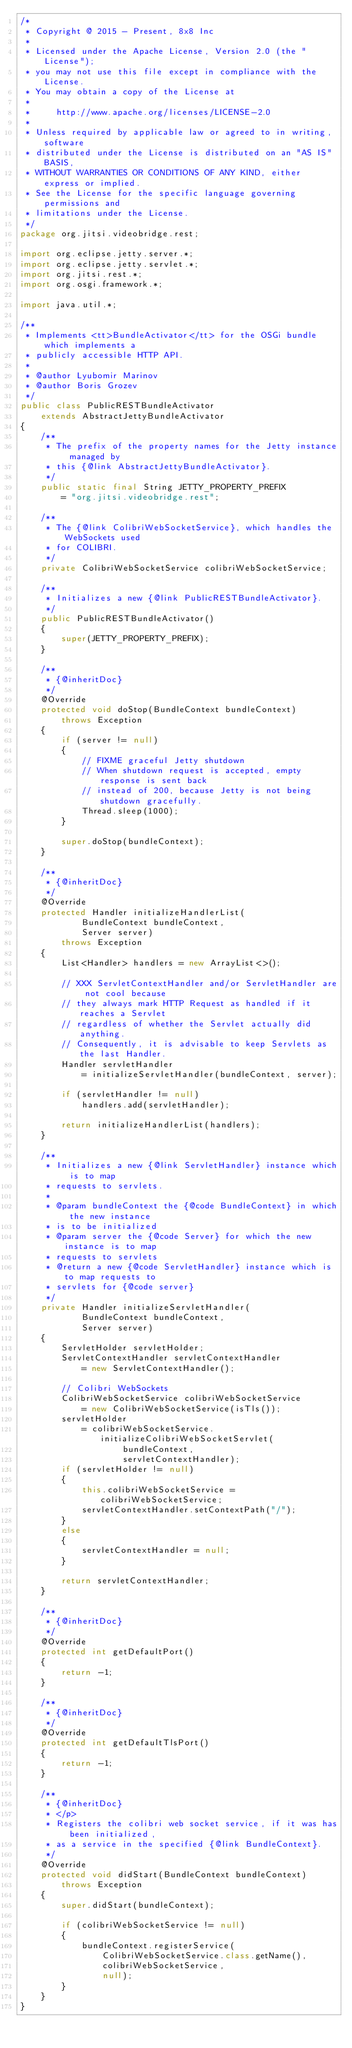<code> <loc_0><loc_0><loc_500><loc_500><_Java_>/*
 * Copyright @ 2015 - Present, 8x8 Inc
 *
 * Licensed under the Apache License, Version 2.0 (the "License");
 * you may not use this file except in compliance with the License.
 * You may obtain a copy of the License at
 *
 *     http://www.apache.org/licenses/LICENSE-2.0
 *
 * Unless required by applicable law or agreed to in writing, software
 * distributed under the License is distributed on an "AS IS" BASIS,
 * WITHOUT WARRANTIES OR CONDITIONS OF ANY KIND, either express or implied.
 * See the License for the specific language governing permissions and
 * limitations under the License.
 */
package org.jitsi.videobridge.rest;

import org.eclipse.jetty.server.*;
import org.eclipse.jetty.servlet.*;
import org.jitsi.rest.*;
import org.osgi.framework.*;

import java.util.*;

/**
 * Implements <tt>BundleActivator</tt> for the OSGi bundle which implements a
 * publicly accessible HTTP API.
 *
 * @author Lyubomir Marinov
 * @author Boris Grozev
 */
public class PublicRESTBundleActivator
    extends AbstractJettyBundleActivator
{
    /**
     * The prefix of the property names for the Jetty instance managed by
     * this {@link AbstractJettyBundleActivator}.
     */
    public static final String JETTY_PROPERTY_PREFIX
        = "org.jitsi.videobridge.rest";

    /**
     * The {@link ColibriWebSocketService}, which handles the WebSockets used
     * for COLIBRI.
     */
    private ColibriWebSocketService colibriWebSocketService;

    /**
     * Initializes a new {@link PublicRESTBundleActivator}.
     */
    public PublicRESTBundleActivator()
    {
        super(JETTY_PROPERTY_PREFIX);
    }

    /**
     * {@inheritDoc}
     */
    @Override
    protected void doStop(BundleContext bundleContext)
        throws Exception
    {
        if (server != null)
        {
            // FIXME graceful Jetty shutdown
            // When shutdown request is accepted, empty response is sent back
            // instead of 200, because Jetty is not being shutdown gracefully.
            Thread.sleep(1000);
        }

        super.doStop(bundleContext);
    }

    /**
     * {@inheritDoc}
     */
    @Override
    protected Handler initializeHandlerList(
            BundleContext bundleContext,
            Server server)
        throws Exception
    {
        List<Handler> handlers = new ArrayList<>();

        // XXX ServletContextHandler and/or ServletHandler are not cool because
        // they always mark HTTP Request as handled if it reaches a Servlet
        // regardless of whether the Servlet actually did anything.
        // Consequently, it is advisable to keep Servlets as the last Handler.
        Handler servletHandler
            = initializeServletHandler(bundleContext, server);

        if (servletHandler != null)
            handlers.add(servletHandler);

        return initializeHandlerList(handlers);
    }

    /**
     * Initializes a new {@link ServletHandler} instance which is to map
     * requests to servlets.
     *
     * @param bundleContext the {@code BundleContext} in which the new instance
     * is to be initialized
     * @param server the {@code Server} for which the new instance is to map
     * requests to servlets
     * @return a new {@code ServletHandler} instance which is to map requests to
     * servlets for {@code server}
     */
    private Handler initializeServletHandler(
            BundleContext bundleContext,
            Server server)
    {
        ServletHolder servletHolder;
        ServletContextHandler servletContextHandler
            = new ServletContextHandler();

        // Colibri WebSockets
        ColibriWebSocketService colibriWebSocketService
            = new ColibriWebSocketService(isTls());
        servletHolder
            = colibriWebSocketService.initializeColibriWebSocketServlet(
                    bundleContext,
                    servletContextHandler);
        if (servletHolder != null)
        {
            this.colibriWebSocketService = colibriWebSocketService;
            servletContextHandler.setContextPath("/");
        }
        else
        {
            servletContextHandler = null;
        }

        return servletContextHandler;
    }

    /**
     * {@inheritDoc}
     */
    @Override
    protected int getDefaultPort()
    {
        return -1;
    }

    /**
     * {@inheritDoc}
     */
    @Override
    protected int getDefaultTlsPort()
    {
        return -1;
    }

    /**
     * {@inheritDoc}
     * </p>
     * Registers the colibri web socket service, if it was has been initialized,
     * as a service in the specified {@link BundleContext}.
     */
    @Override
    protected void didStart(BundleContext bundleContext)
        throws Exception
    {
        super.didStart(bundleContext);

        if (colibriWebSocketService != null)
        {
            bundleContext.registerService(
                ColibriWebSocketService.class.getName(),
                colibriWebSocketService,
                null);
        }
    }
}
</code> 